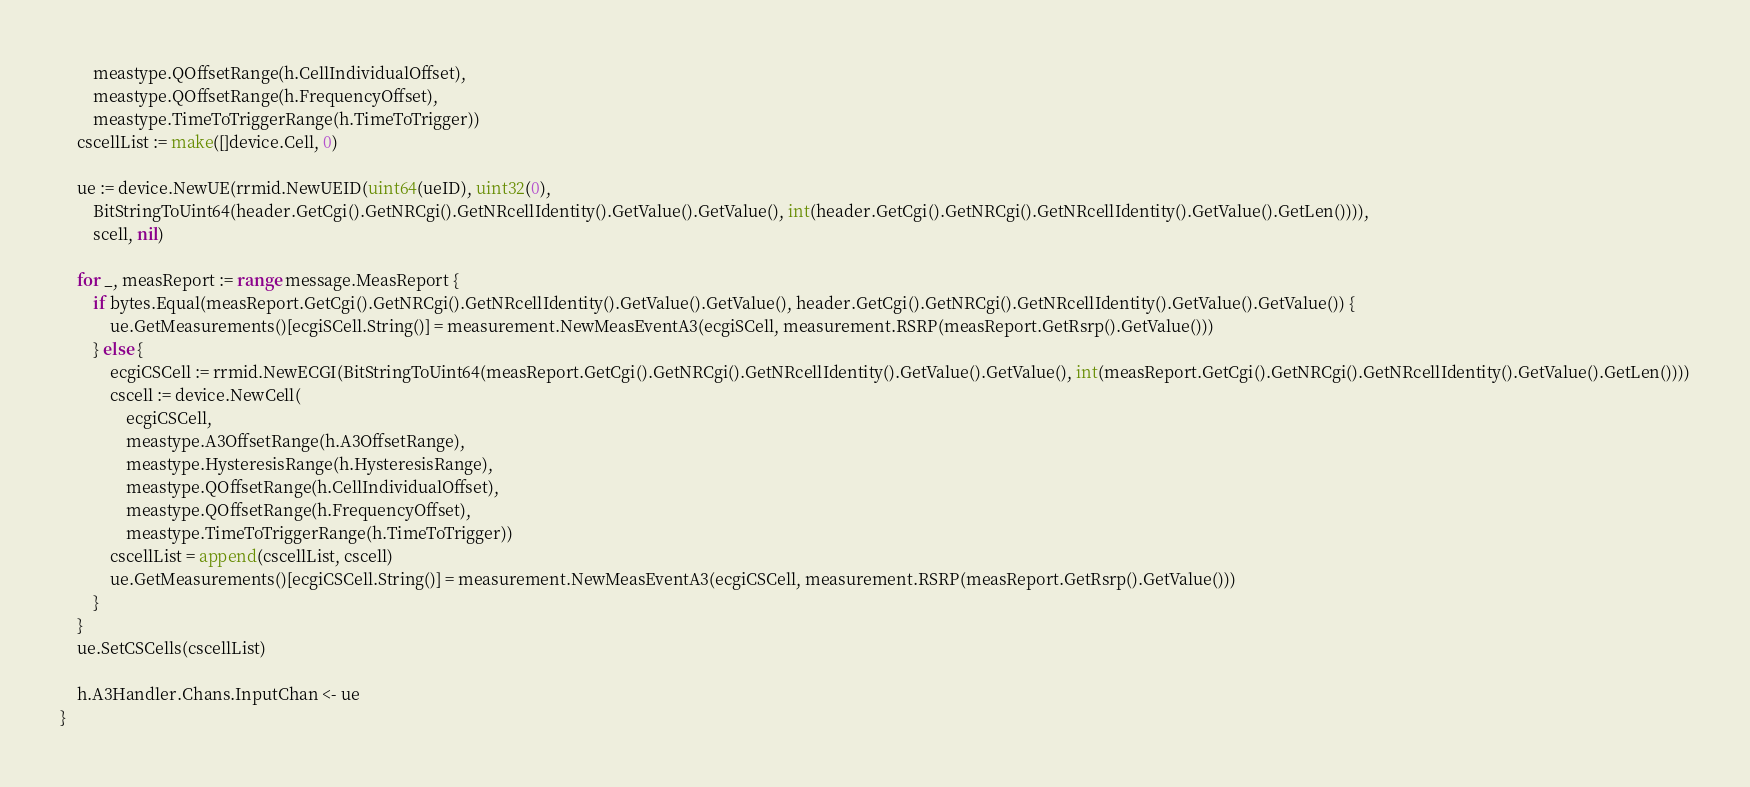Convert code to text. <code><loc_0><loc_0><loc_500><loc_500><_Go_>		meastype.QOffsetRange(h.CellIndividualOffset),
		meastype.QOffsetRange(h.FrequencyOffset),
		meastype.TimeToTriggerRange(h.TimeToTrigger))
	cscellList := make([]device.Cell, 0)

	ue := device.NewUE(rrmid.NewUEID(uint64(ueID), uint32(0),
		BitStringToUint64(header.GetCgi().GetNRCgi().GetNRcellIdentity().GetValue().GetValue(), int(header.GetCgi().GetNRCgi().GetNRcellIdentity().GetValue().GetLen()))),
		scell, nil)

	for _, measReport := range message.MeasReport {
		if bytes.Equal(measReport.GetCgi().GetNRCgi().GetNRcellIdentity().GetValue().GetValue(), header.GetCgi().GetNRCgi().GetNRcellIdentity().GetValue().GetValue()) {
			ue.GetMeasurements()[ecgiSCell.String()] = measurement.NewMeasEventA3(ecgiSCell, measurement.RSRP(measReport.GetRsrp().GetValue()))
		} else {
			ecgiCSCell := rrmid.NewECGI(BitStringToUint64(measReport.GetCgi().GetNRCgi().GetNRcellIdentity().GetValue().GetValue(), int(measReport.GetCgi().GetNRCgi().GetNRcellIdentity().GetValue().GetLen())))
			cscell := device.NewCell(
				ecgiCSCell,
				meastype.A3OffsetRange(h.A3OffsetRange),
				meastype.HysteresisRange(h.HysteresisRange),
				meastype.QOffsetRange(h.CellIndividualOffset),
				meastype.QOffsetRange(h.FrequencyOffset),
				meastype.TimeToTriggerRange(h.TimeToTrigger))
			cscellList = append(cscellList, cscell)
			ue.GetMeasurements()[ecgiCSCell.String()] = measurement.NewMeasEventA3(ecgiCSCell, measurement.RSRP(measReport.GetRsrp().GetValue()))
		}
	}
	ue.SetCSCells(cscellList)

	h.A3Handler.Chans.InputChan <- ue
}
</code> 